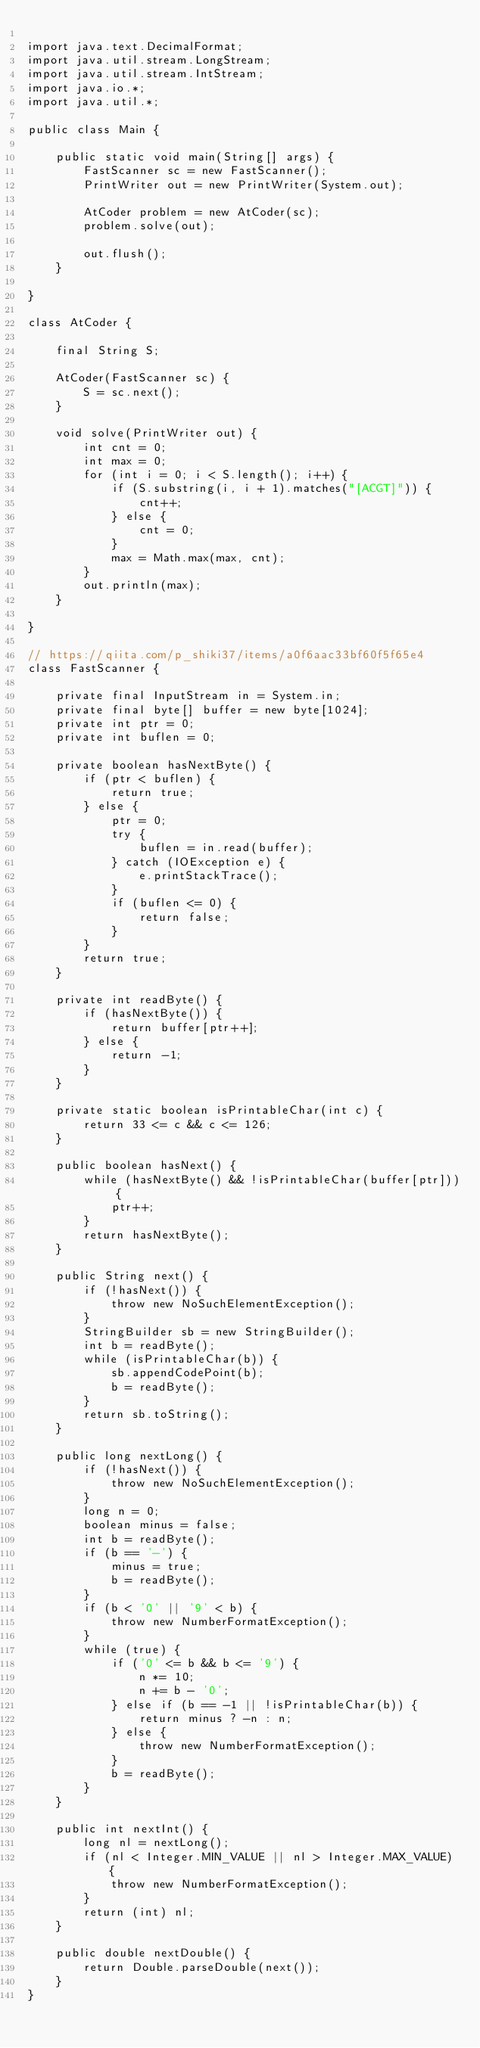Convert code to text. <code><loc_0><loc_0><loc_500><loc_500><_Java_>
import java.text.DecimalFormat;
import java.util.stream.LongStream;
import java.util.stream.IntStream;
import java.io.*;
import java.util.*;

public class Main {
    
    public static void main(String[] args) {
        FastScanner sc = new FastScanner();
        PrintWriter out = new PrintWriter(System.out);
        
        AtCoder problem = new AtCoder(sc);
        problem.solve(out);
        
        out.flush();
    }
    
}

class AtCoder {
    
    final String S;
    
    AtCoder(FastScanner sc) {
        S = sc.next();
    }
    
    void solve(PrintWriter out) {
        int cnt = 0;
        int max = 0;
        for (int i = 0; i < S.length(); i++) {
            if (S.substring(i, i + 1).matches("[ACGT]")) {
                cnt++;
            } else {
                cnt = 0;
            }
            max = Math.max(max, cnt);
        }
        out.println(max);
    }
    
}

// https://qiita.com/p_shiki37/items/a0f6aac33bf60f5f65e4
class FastScanner {
    
    private final InputStream in = System.in;
    private final byte[] buffer = new byte[1024];
    private int ptr = 0;
    private int buflen = 0;
    
    private boolean hasNextByte() {
        if (ptr < buflen) {
            return true;
        } else {
            ptr = 0;
            try {
                buflen = in.read(buffer);
            } catch (IOException e) {
                e.printStackTrace();
            }
            if (buflen <= 0) {
                return false;
            }
        }
        return true;
    }
    
    private int readByte() {
        if (hasNextByte()) {
            return buffer[ptr++];
        } else {
            return -1;
        }
    }
    
    private static boolean isPrintableChar(int c) {
        return 33 <= c && c <= 126;
    }
    
    public boolean hasNext() {
        while (hasNextByte() && !isPrintableChar(buffer[ptr])) {
            ptr++;
        }
        return hasNextByte();
    }
    
    public String next() {
        if (!hasNext()) {
            throw new NoSuchElementException();
        }
        StringBuilder sb = new StringBuilder();
        int b = readByte();
        while (isPrintableChar(b)) {
            sb.appendCodePoint(b);
            b = readByte();
        }
        return sb.toString();
    }
    
    public long nextLong() {
        if (!hasNext()) {
            throw new NoSuchElementException();
        }
        long n = 0;
        boolean minus = false;
        int b = readByte();
        if (b == '-') {
            minus = true;
            b = readByte();
        }
        if (b < '0' || '9' < b) {
            throw new NumberFormatException();
        }
        while (true) {
            if ('0' <= b && b <= '9') {
                n *= 10;
                n += b - '0';
            } else if (b == -1 || !isPrintableChar(b)) {
                return minus ? -n : n;
            } else {
                throw new NumberFormatException();
            }
            b = readByte();
        }
    }
    
    public int nextInt() {
        long nl = nextLong();
        if (nl < Integer.MIN_VALUE || nl > Integer.MAX_VALUE) {
            throw new NumberFormatException();
        }
        return (int) nl;
    }
    
    public double nextDouble() {
        return Double.parseDouble(next());
    }
}
</code> 